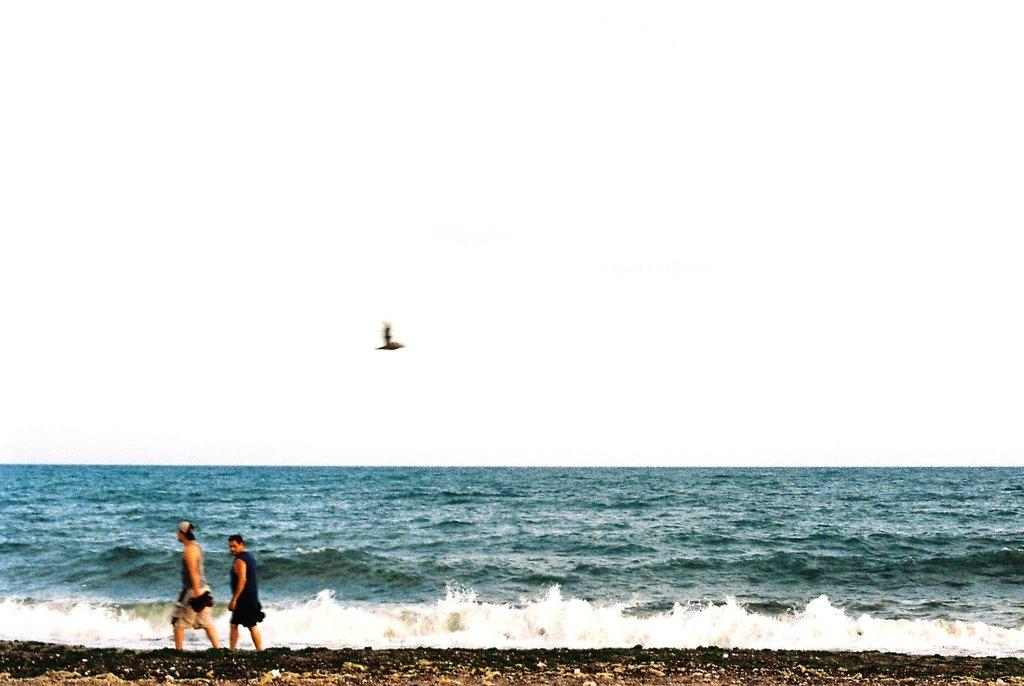What are the two people in the image doing? The two people in the image are walking. Where are the people located in the image? The people are located at the bottom left hand side of the image. What is in the middle of the image? There is a sea in the middle of the image. What can be seen in the background of the image? The background of the image is the sky. What type of polish is the lawyer applying to the chairs in the image? There is no lawyer, polish, or chairs present in the image. 